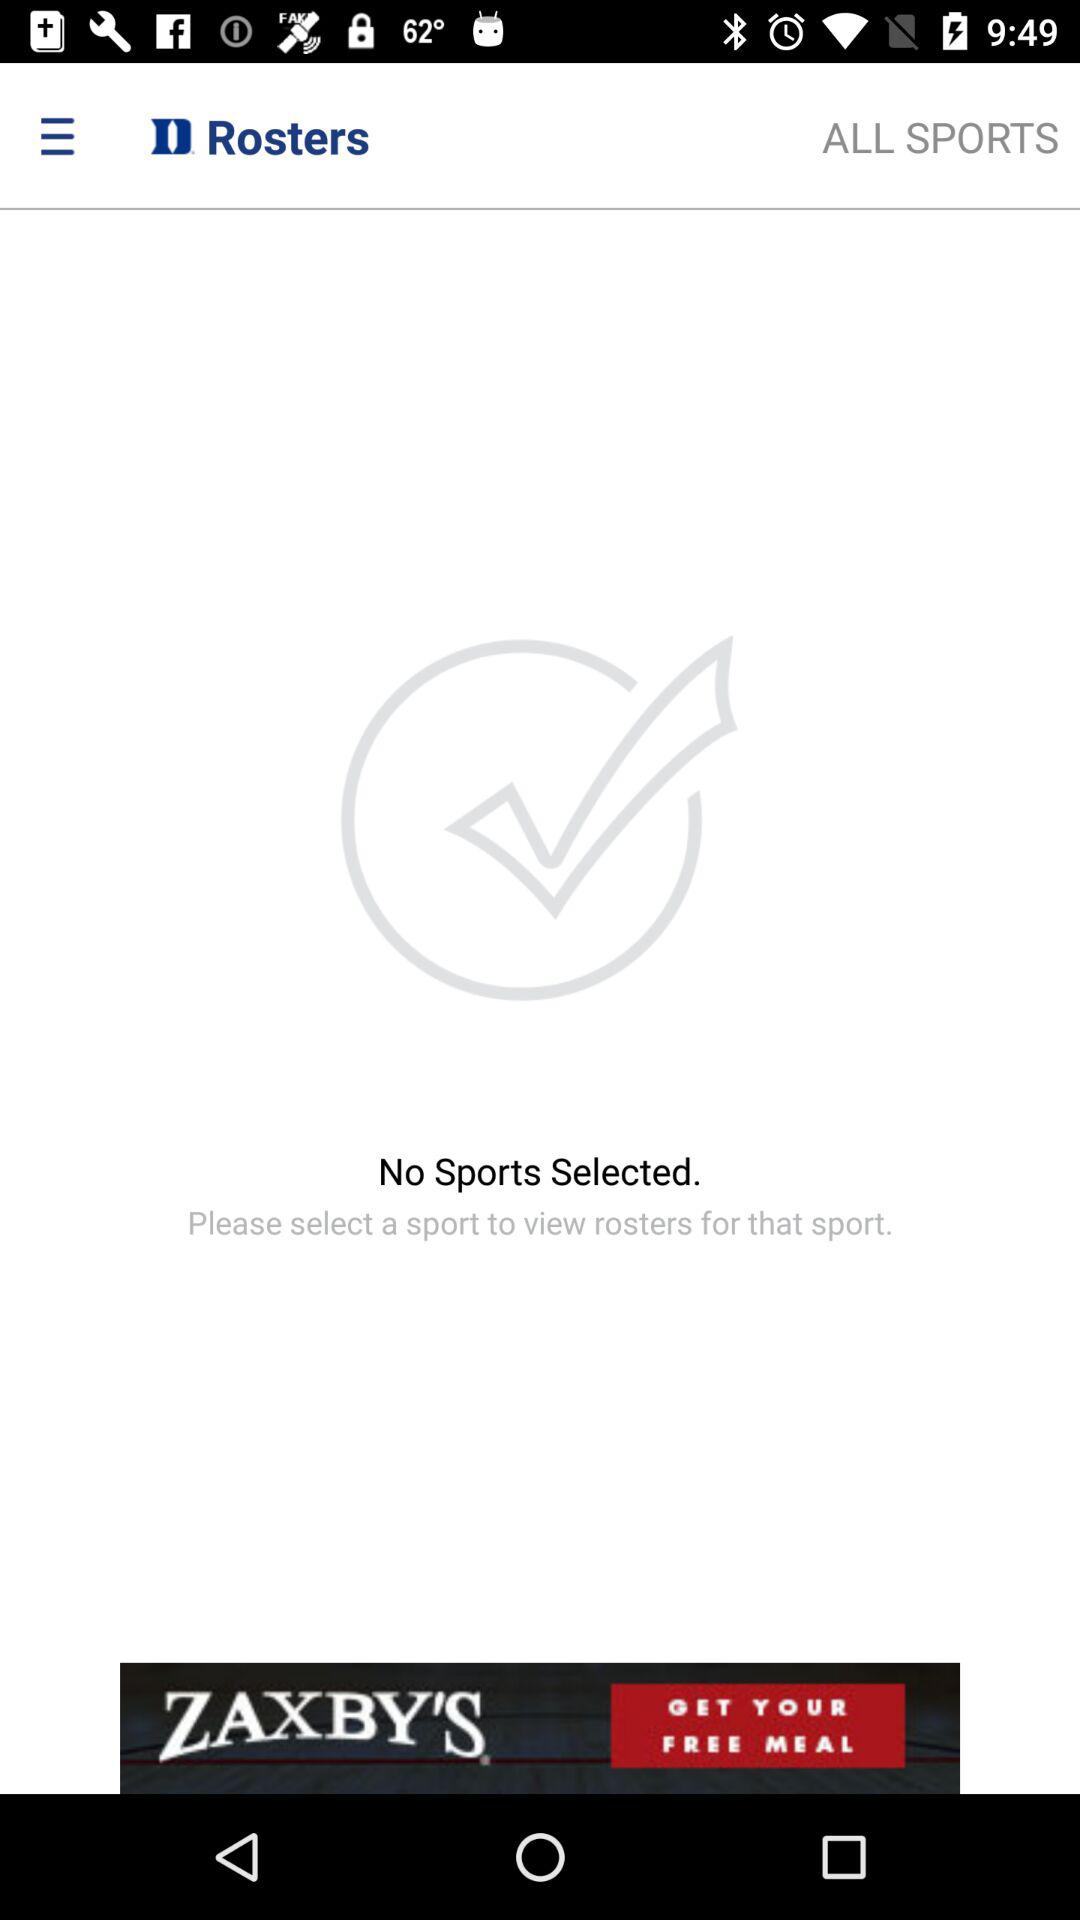Are there any sports selected? There are no sports selected. 